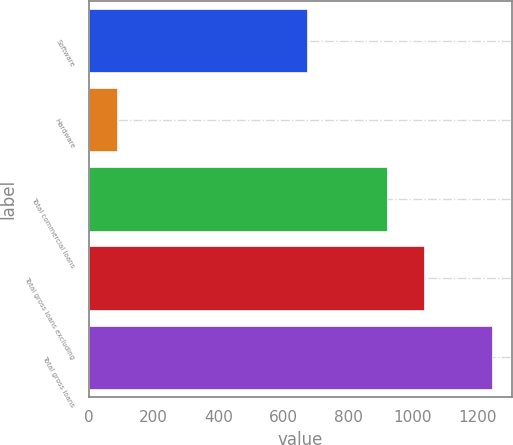<chart> <loc_0><loc_0><loc_500><loc_500><bar_chart><fcel>Software<fcel>Hardware<fcel>Total commercial loans<fcel>Total gross loans excluding<fcel>Total gross loans<nl><fcel>674<fcel>89<fcel>920<fcel>1035.4<fcel>1243<nl></chart> 